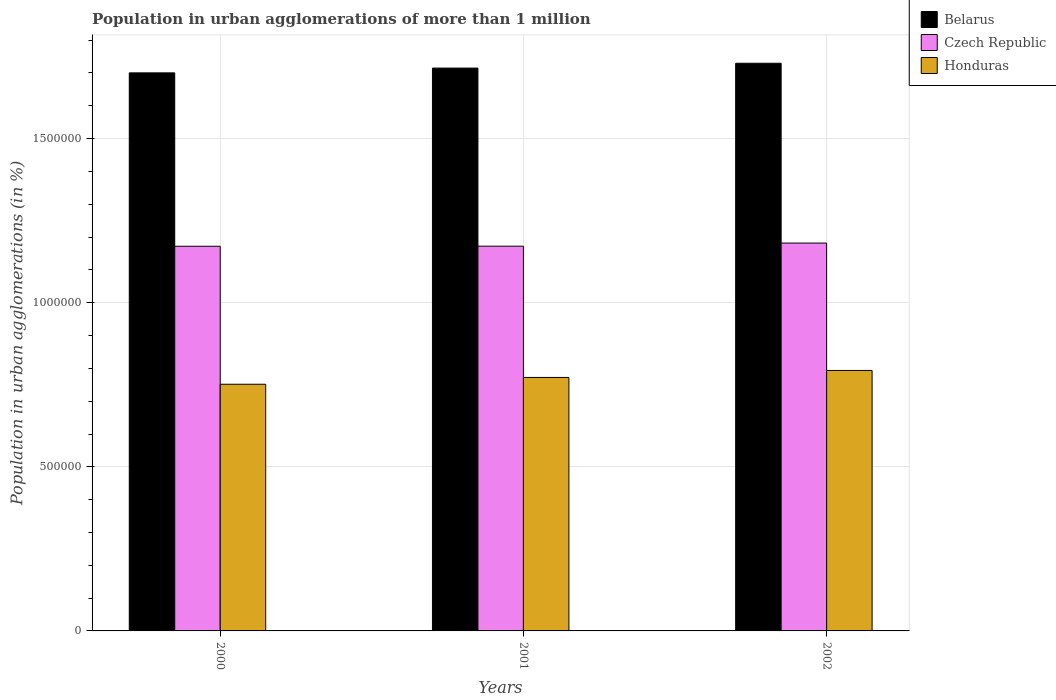Are the number of bars per tick equal to the number of legend labels?
Your response must be concise. Yes. How many bars are there on the 1st tick from the left?
Ensure brevity in your answer.  3. How many bars are there on the 2nd tick from the right?
Offer a terse response. 3. What is the label of the 1st group of bars from the left?
Offer a very short reply. 2000. In how many cases, is the number of bars for a given year not equal to the number of legend labels?
Offer a very short reply. 0. What is the population in urban agglomerations in Belarus in 2000?
Ensure brevity in your answer.  1.70e+06. Across all years, what is the maximum population in urban agglomerations in Belarus?
Make the answer very short. 1.73e+06. Across all years, what is the minimum population in urban agglomerations in Belarus?
Your response must be concise. 1.70e+06. In which year was the population in urban agglomerations in Belarus maximum?
Your answer should be very brief. 2002. What is the total population in urban agglomerations in Czech Republic in the graph?
Offer a very short reply. 3.53e+06. What is the difference between the population in urban agglomerations in Czech Republic in 2000 and that in 2002?
Provide a succinct answer. -9800. What is the difference between the population in urban agglomerations in Czech Republic in 2001 and the population in urban agglomerations in Belarus in 2002?
Offer a very short reply. -5.57e+05. What is the average population in urban agglomerations in Belarus per year?
Your response must be concise. 1.71e+06. In the year 2000, what is the difference between the population in urban agglomerations in Honduras and population in urban agglomerations in Belarus?
Your response must be concise. -9.49e+05. In how many years, is the population in urban agglomerations in Honduras greater than 500000 %?
Offer a very short reply. 3. What is the ratio of the population in urban agglomerations in Belarus in 2001 to that in 2002?
Keep it short and to the point. 0.99. Is the population in urban agglomerations in Honduras in 2000 less than that in 2002?
Your response must be concise. Yes. What is the difference between the highest and the second highest population in urban agglomerations in Belarus?
Your answer should be very brief. 1.47e+04. What is the difference between the highest and the lowest population in urban agglomerations in Honduras?
Keep it short and to the point. 4.21e+04. In how many years, is the population in urban agglomerations in Czech Republic greater than the average population in urban agglomerations in Czech Republic taken over all years?
Make the answer very short. 1. Is the sum of the population in urban agglomerations in Belarus in 2001 and 2002 greater than the maximum population in urban agglomerations in Czech Republic across all years?
Your answer should be compact. Yes. What does the 3rd bar from the left in 2001 represents?
Give a very brief answer. Honduras. What does the 2nd bar from the right in 2002 represents?
Your response must be concise. Czech Republic. Are all the bars in the graph horizontal?
Keep it short and to the point. No. How many years are there in the graph?
Your answer should be very brief. 3. What is the difference between two consecutive major ticks on the Y-axis?
Ensure brevity in your answer.  5.00e+05. Where does the legend appear in the graph?
Your answer should be very brief. Top right. How many legend labels are there?
Provide a succinct answer. 3. How are the legend labels stacked?
Your answer should be compact. Vertical. What is the title of the graph?
Keep it short and to the point. Population in urban agglomerations of more than 1 million. Does "Zambia" appear as one of the legend labels in the graph?
Make the answer very short. No. What is the label or title of the Y-axis?
Ensure brevity in your answer.  Population in urban agglomerations (in %). What is the Population in urban agglomerations (in %) in Belarus in 2000?
Ensure brevity in your answer.  1.70e+06. What is the Population in urban agglomerations (in %) in Czech Republic in 2000?
Your answer should be compact. 1.17e+06. What is the Population in urban agglomerations (in %) of Honduras in 2000?
Give a very brief answer. 7.52e+05. What is the Population in urban agglomerations (in %) of Belarus in 2001?
Keep it short and to the point. 1.71e+06. What is the Population in urban agglomerations (in %) in Czech Republic in 2001?
Your answer should be compact. 1.17e+06. What is the Population in urban agglomerations (in %) of Honduras in 2001?
Keep it short and to the point. 7.72e+05. What is the Population in urban agglomerations (in %) in Belarus in 2002?
Your answer should be compact. 1.73e+06. What is the Population in urban agglomerations (in %) of Czech Republic in 2002?
Offer a very short reply. 1.18e+06. What is the Population in urban agglomerations (in %) of Honduras in 2002?
Make the answer very short. 7.94e+05. Across all years, what is the maximum Population in urban agglomerations (in %) of Belarus?
Ensure brevity in your answer.  1.73e+06. Across all years, what is the maximum Population in urban agglomerations (in %) in Czech Republic?
Make the answer very short. 1.18e+06. Across all years, what is the maximum Population in urban agglomerations (in %) in Honduras?
Ensure brevity in your answer.  7.94e+05. Across all years, what is the minimum Population in urban agglomerations (in %) in Belarus?
Provide a short and direct response. 1.70e+06. Across all years, what is the minimum Population in urban agglomerations (in %) in Czech Republic?
Your answer should be very brief. 1.17e+06. Across all years, what is the minimum Population in urban agglomerations (in %) in Honduras?
Your answer should be compact. 7.52e+05. What is the total Population in urban agglomerations (in %) of Belarus in the graph?
Your answer should be very brief. 5.14e+06. What is the total Population in urban agglomerations (in %) of Czech Republic in the graph?
Your answer should be compact. 3.53e+06. What is the total Population in urban agglomerations (in %) of Honduras in the graph?
Your response must be concise. 2.32e+06. What is the difference between the Population in urban agglomerations (in %) in Belarus in 2000 and that in 2001?
Offer a terse response. -1.46e+04. What is the difference between the Population in urban agglomerations (in %) in Czech Republic in 2000 and that in 2001?
Offer a terse response. -236. What is the difference between the Population in urban agglomerations (in %) of Honduras in 2000 and that in 2001?
Give a very brief answer. -2.07e+04. What is the difference between the Population in urban agglomerations (in %) of Belarus in 2000 and that in 2002?
Your answer should be very brief. -2.93e+04. What is the difference between the Population in urban agglomerations (in %) of Czech Republic in 2000 and that in 2002?
Provide a succinct answer. -9800. What is the difference between the Population in urban agglomerations (in %) of Honduras in 2000 and that in 2002?
Ensure brevity in your answer.  -4.21e+04. What is the difference between the Population in urban agglomerations (in %) of Belarus in 2001 and that in 2002?
Keep it short and to the point. -1.47e+04. What is the difference between the Population in urban agglomerations (in %) in Czech Republic in 2001 and that in 2002?
Give a very brief answer. -9564. What is the difference between the Population in urban agglomerations (in %) of Honduras in 2001 and that in 2002?
Provide a short and direct response. -2.13e+04. What is the difference between the Population in urban agglomerations (in %) in Belarus in 2000 and the Population in urban agglomerations (in %) in Czech Republic in 2001?
Provide a succinct answer. 5.28e+05. What is the difference between the Population in urban agglomerations (in %) of Belarus in 2000 and the Population in urban agglomerations (in %) of Honduras in 2001?
Ensure brevity in your answer.  9.28e+05. What is the difference between the Population in urban agglomerations (in %) in Czech Republic in 2000 and the Population in urban agglomerations (in %) in Honduras in 2001?
Your response must be concise. 4.00e+05. What is the difference between the Population in urban agglomerations (in %) of Belarus in 2000 and the Population in urban agglomerations (in %) of Czech Republic in 2002?
Offer a terse response. 5.19e+05. What is the difference between the Population in urban agglomerations (in %) of Belarus in 2000 and the Population in urban agglomerations (in %) of Honduras in 2002?
Keep it short and to the point. 9.07e+05. What is the difference between the Population in urban agglomerations (in %) in Czech Republic in 2000 and the Population in urban agglomerations (in %) in Honduras in 2002?
Make the answer very short. 3.78e+05. What is the difference between the Population in urban agglomerations (in %) in Belarus in 2001 and the Population in urban agglomerations (in %) in Czech Republic in 2002?
Offer a terse response. 5.33e+05. What is the difference between the Population in urban agglomerations (in %) of Belarus in 2001 and the Population in urban agglomerations (in %) of Honduras in 2002?
Your answer should be very brief. 9.21e+05. What is the difference between the Population in urban agglomerations (in %) of Czech Republic in 2001 and the Population in urban agglomerations (in %) of Honduras in 2002?
Your answer should be very brief. 3.79e+05. What is the average Population in urban agglomerations (in %) of Belarus per year?
Your response must be concise. 1.71e+06. What is the average Population in urban agglomerations (in %) in Czech Republic per year?
Offer a terse response. 1.18e+06. What is the average Population in urban agglomerations (in %) in Honduras per year?
Your response must be concise. 7.73e+05. In the year 2000, what is the difference between the Population in urban agglomerations (in %) of Belarus and Population in urban agglomerations (in %) of Czech Republic?
Your response must be concise. 5.28e+05. In the year 2000, what is the difference between the Population in urban agglomerations (in %) in Belarus and Population in urban agglomerations (in %) in Honduras?
Provide a short and direct response. 9.49e+05. In the year 2000, what is the difference between the Population in urban agglomerations (in %) of Czech Republic and Population in urban agglomerations (in %) of Honduras?
Keep it short and to the point. 4.20e+05. In the year 2001, what is the difference between the Population in urban agglomerations (in %) of Belarus and Population in urban agglomerations (in %) of Czech Republic?
Offer a terse response. 5.43e+05. In the year 2001, what is the difference between the Population in urban agglomerations (in %) in Belarus and Population in urban agglomerations (in %) in Honduras?
Offer a very short reply. 9.43e+05. In the year 2001, what is the difference between the Population in urban agglomerations (in %) in Czech Republic and Population in urban agglomerations (in %) in Honduras?
Keep it short and to the point. 4.00e+05. In the year 2002, what is the difference between the Population in urban agglomerations (in %) in Belarus and Population in urban agglomerations (in %) in Czech Republic?
Provide a succinct answer. 5.48e+05. In the year 2002, what is the difference between the Population in urban agglomerations (in %) in Belarus and Population in urban agglomerations (in %) in Honduras?
Make the answer very short. 9.36e+05. In the year 2002, what is the difference between the Population in urban agglomerations (in %) in Czech Republic and Population in urban agglomerations (in %) in Honduras?
Make the answer very short. 3.88e+05. What is the ratio of the Population in urban agglomerations (in %) of Belarus in 2000 to that in 2001?
Offer a very short reply. 0.99. What is the ratio of the Population in urban agglomerations (in %) in Honduras in 2000 to that in 2001?
Your answer should be compact. 0.97. What is the ratio of the Population in urban agglomerations (in %) in Belarus in 2000 to that in 2002?
Offer a terse response. 0.98. What is the ratio of the Population in urban agglomerations (in %) of Honduras in 2000 to that in 2002?
Give a very brief answer. 0.95. What is the ratio of the Population in urban agglomerations (in %) of Belarus in 2001 to that in 2002?
Offer a terse response. 0.99. What is the ratio of the Population in urban agglomerations (in %) in Honduras in 2001 to that in 2002?
Your response must be concise. 0.97. What is the difference between the highest and the second highest Population in urban agglomerations (in %) of Belarus?
Offer a very short reply. 1.47e+04. What is the difference between the highest and the second highest Population in urban agglomerations (in %) of Czech Republic?
Ensure brevity in your answer.  9564. What is the difference between the highest and the second highest Population in urban agglomerations (in %) of Honduras?
Make the answer very short. 2.13e+04. What is the difference between the highest and the lowest Population in urban agglomerations (in %) in Belarus?
Ensure brevity in your answer.  2.93e+04. What is the difference between the highest and the lowest Population in urban agglomerations (in %) in Czech Republic?
Offer a terse response. 9800. What is the difference between the highest and the lowest Population in urban agglomerations (in %) in Honduras?
Provide a succinct answer. 4.21e+04. 